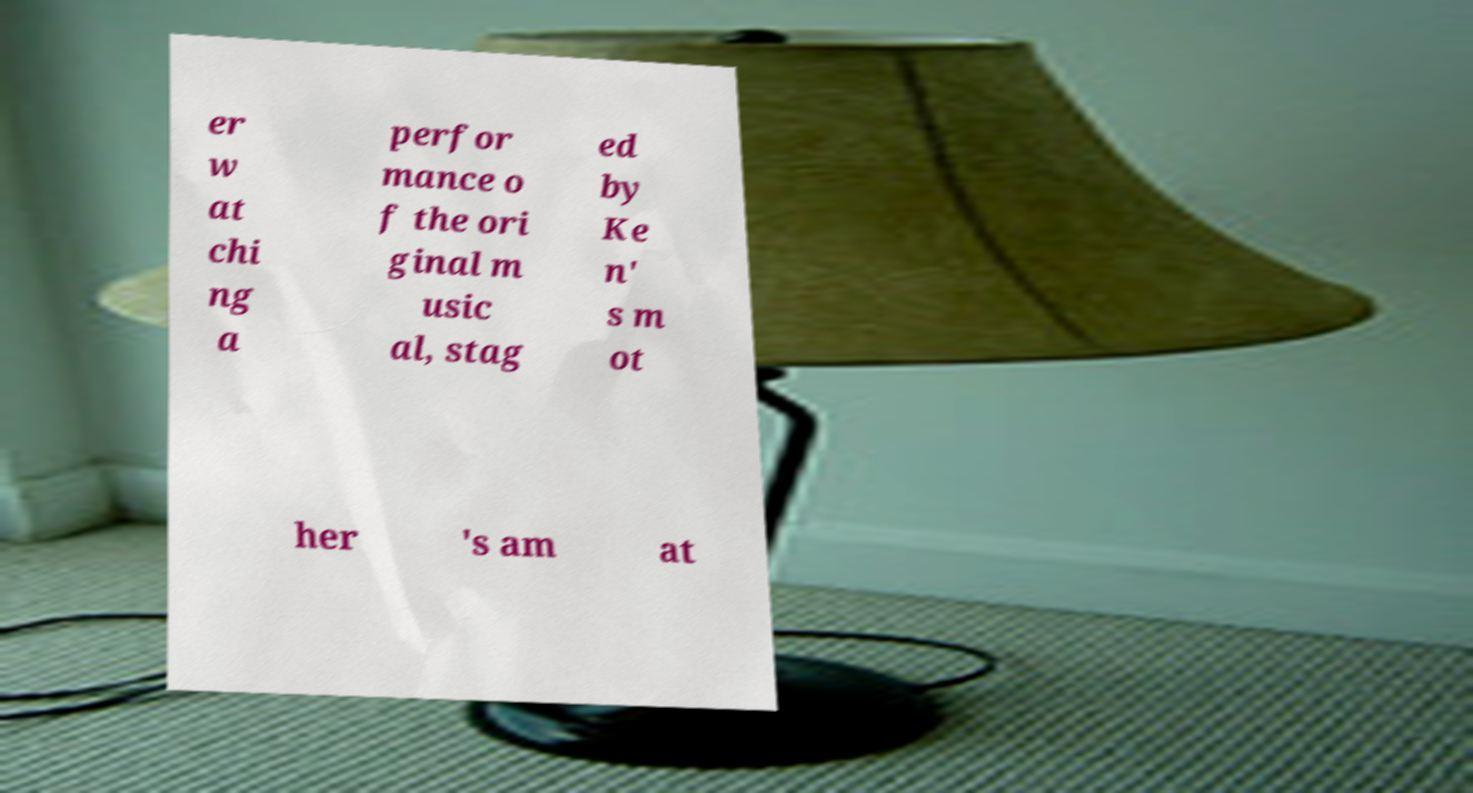Can you accurately transcribe the text from the provided image for me? er w at chi ng a perfor mance o f the ori ginal m usic al, stag ed by Ke n' s m ot her 's am at 